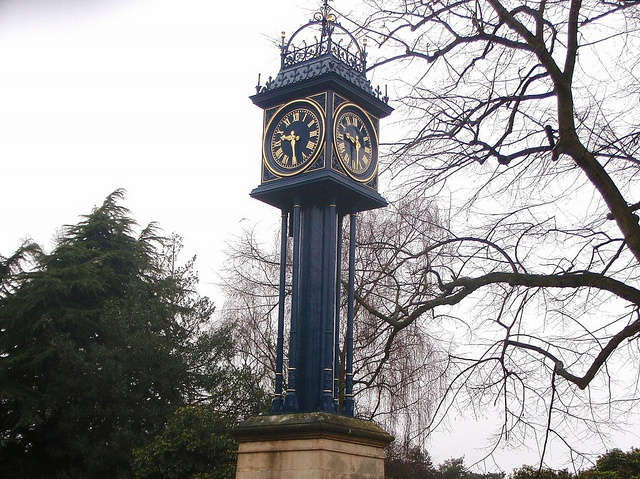Describe the objects in this image and their specific colors. I can see clock in darkgray, gray, black, and darkblue tones and clock in darkgray, gray, and black tones in this image. 